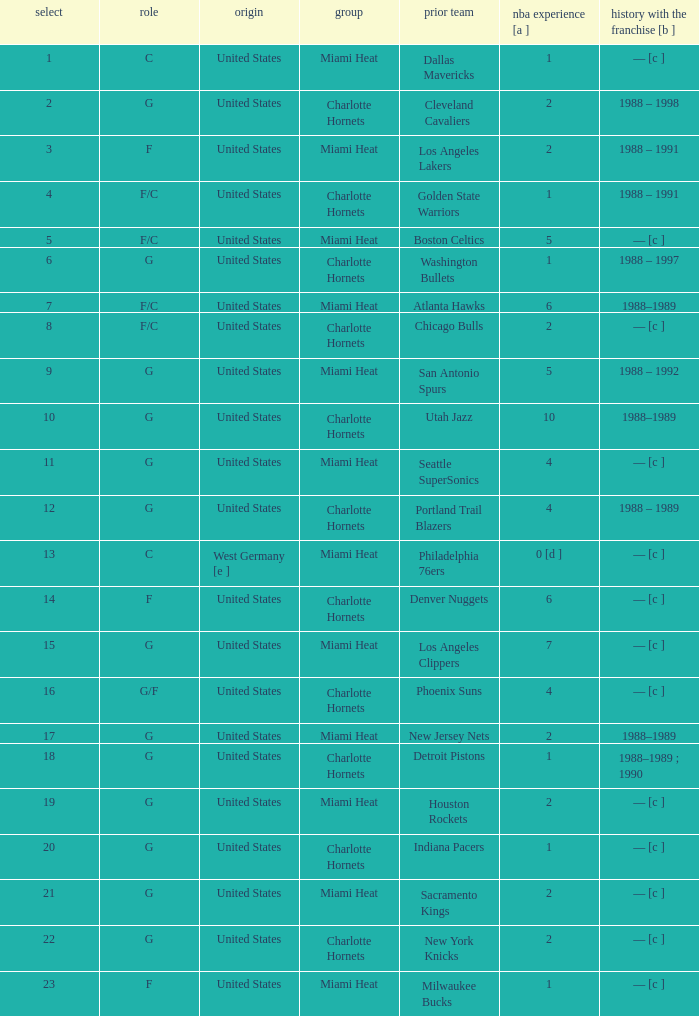How many NBA years did the player from the United States who was previously on the los angeles lakers have? 2.0. 